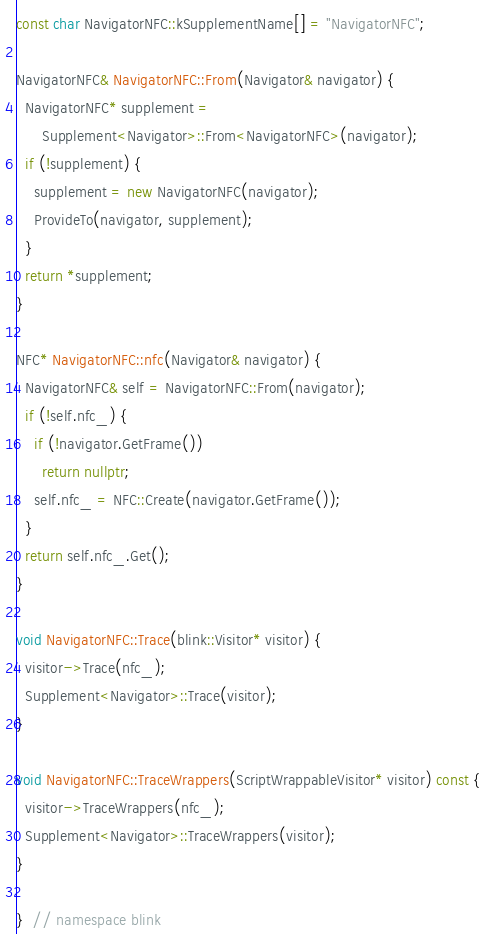<code> <loc_0><loc_0><loc_500><loc_500><_C++_>const char NavigatorNFC::kSupplementName[] = "NavigatorNFC";

NavigatorNFC& NavigatorNFC::From(Navigator& navigator) {
  NavigatorNFC* supplement =
      Supplement<Navigator>::From<NavigatorNFC>(navigator);
  if (!supplement) {
    supplement = new NavigatorNFC(navigator);
    ProvideTo(navigator, supplement);
  }
  return *supplement;
}

NFC* NavigatorNFC::nfc(Navigator& navigator) {
  NavigatorNFC& self = NavigatorNFC::From(navigator);
  if (!self.nfc_) {
    if (!navigator.GetFrame())
      return nullptr;
    self.nfc_ = NFC::Create(navigator.GetFrame());
  }
  return self.nfc_.Get();
}

void NavigatorNFC::Trace(blink::Visitor* visitor) {
  visitor->Trace(nfc_);
  Supplement<Navigator>::Trace(visitor);
}

void NavigatorNFC::TraceWrappers(ScriptWrappableVisitor* visitor) const {
  visitor->TraceWrappers(nfc_);
  Supplement<Navigator>::TraceWrappers(visitor);
}

}  // namespace blink
</code> 